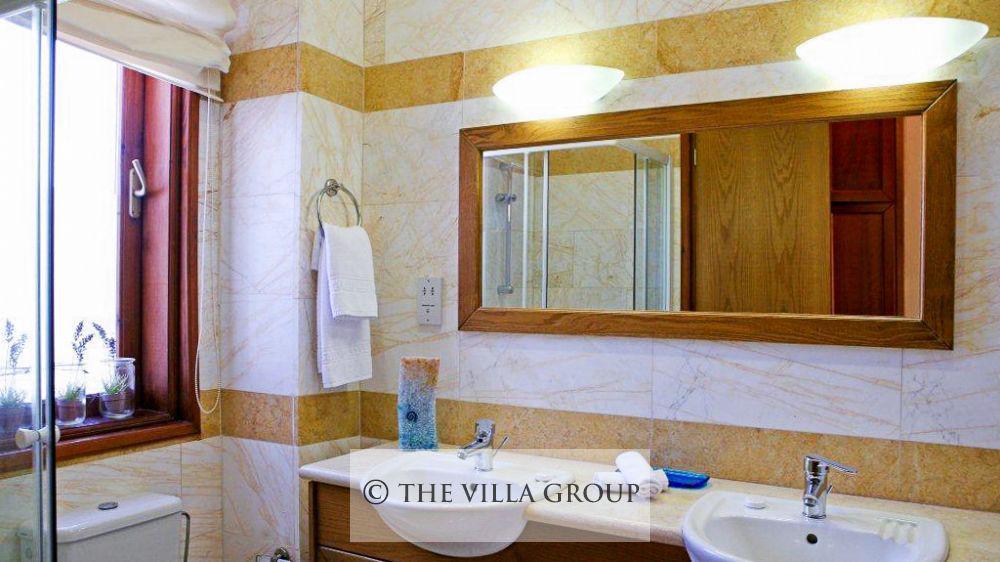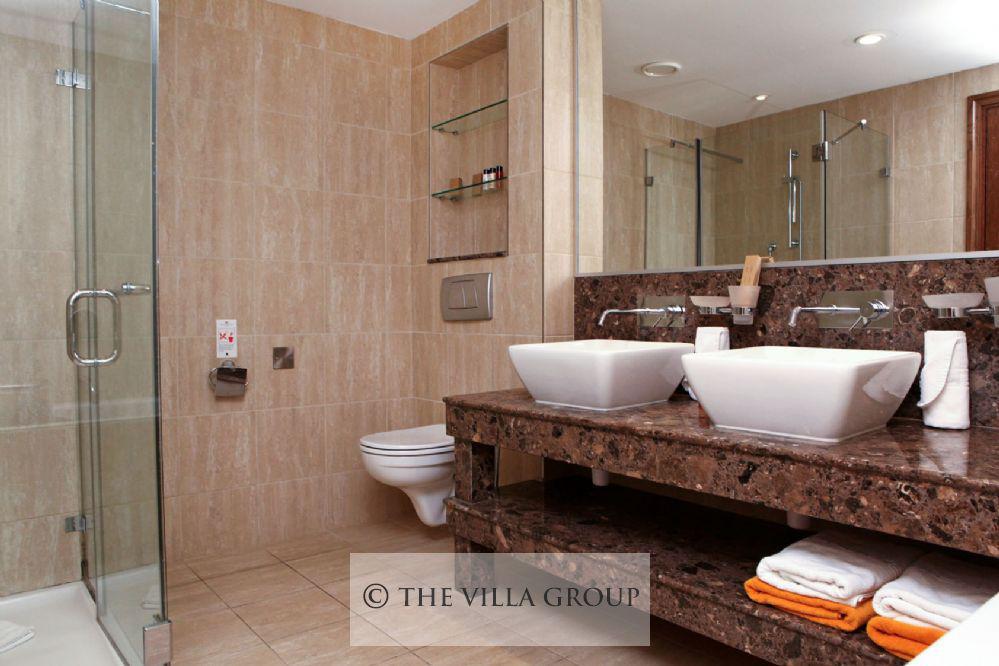The first image is the image on the left, the second image is the image on the right. For the images shown, is this caption "There are at least 3 toilets next to showers." true? Answer yes or no. No. 